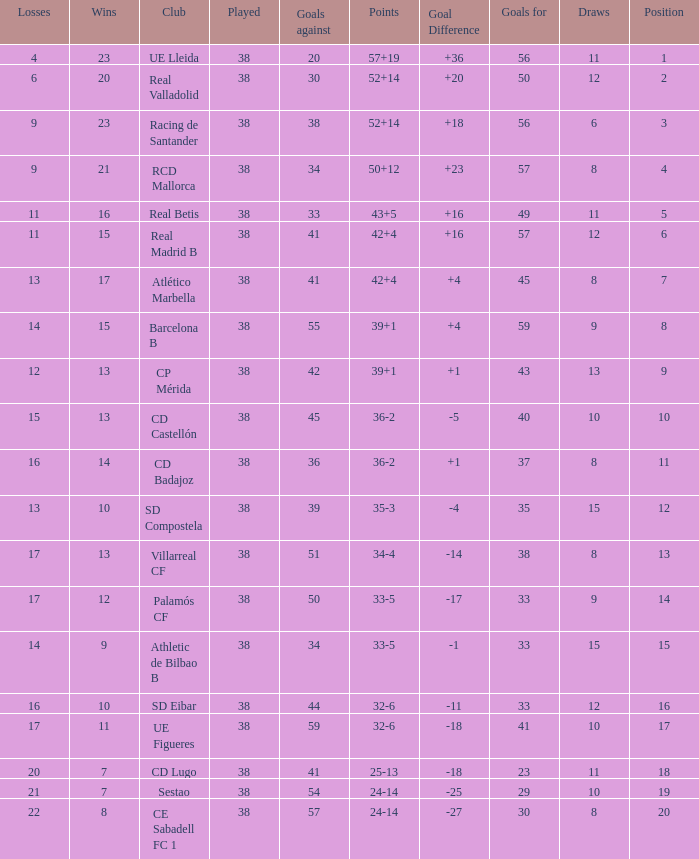What is the highest position with less than 17 losses, more than 57 goals, and a goal difference less than 4? None. 